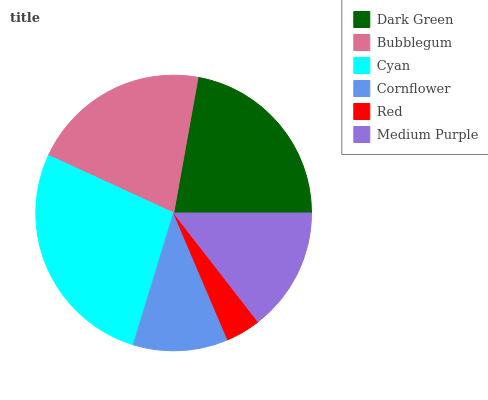Is Red the minimum?
Answer yes or no. Yes. Is Cyan the maximum?
Answer yes or no. Yes. Is Bubblegum the minimum?
Answer yes or no. No. Is Bubblegum the maximum?
Answer yes or no. No. Is Dark Green greater than Bubblegum?
Answer yes or no. Yes. Is Bubblegum less than Dark Green?
Answer yes or no. Yes. Is Bubblegum greater than Dark Green?
Answer yes or no. No. Is Dark Green less than Bubblegum?
Answer yes or no. No. Is Bubblegum the high median?
Answer yes or no. Yes. Is Medium Purple the low median?
Answer yes or no. Yes. Is Red the high median?
Answer yes or no. No. Is Dark Green the low median?
Answer yes or no. No. 